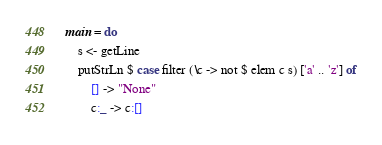<code> <loc_0><loc_0><loc_500><loc_500><_Haskell_>main = do
    s <- getLine
    putStrLn $ case filter (\c -> not $ elem c s) ['a' .. 'z'] of
        [] -> "None"
        c:_ -> c:[]</code> 